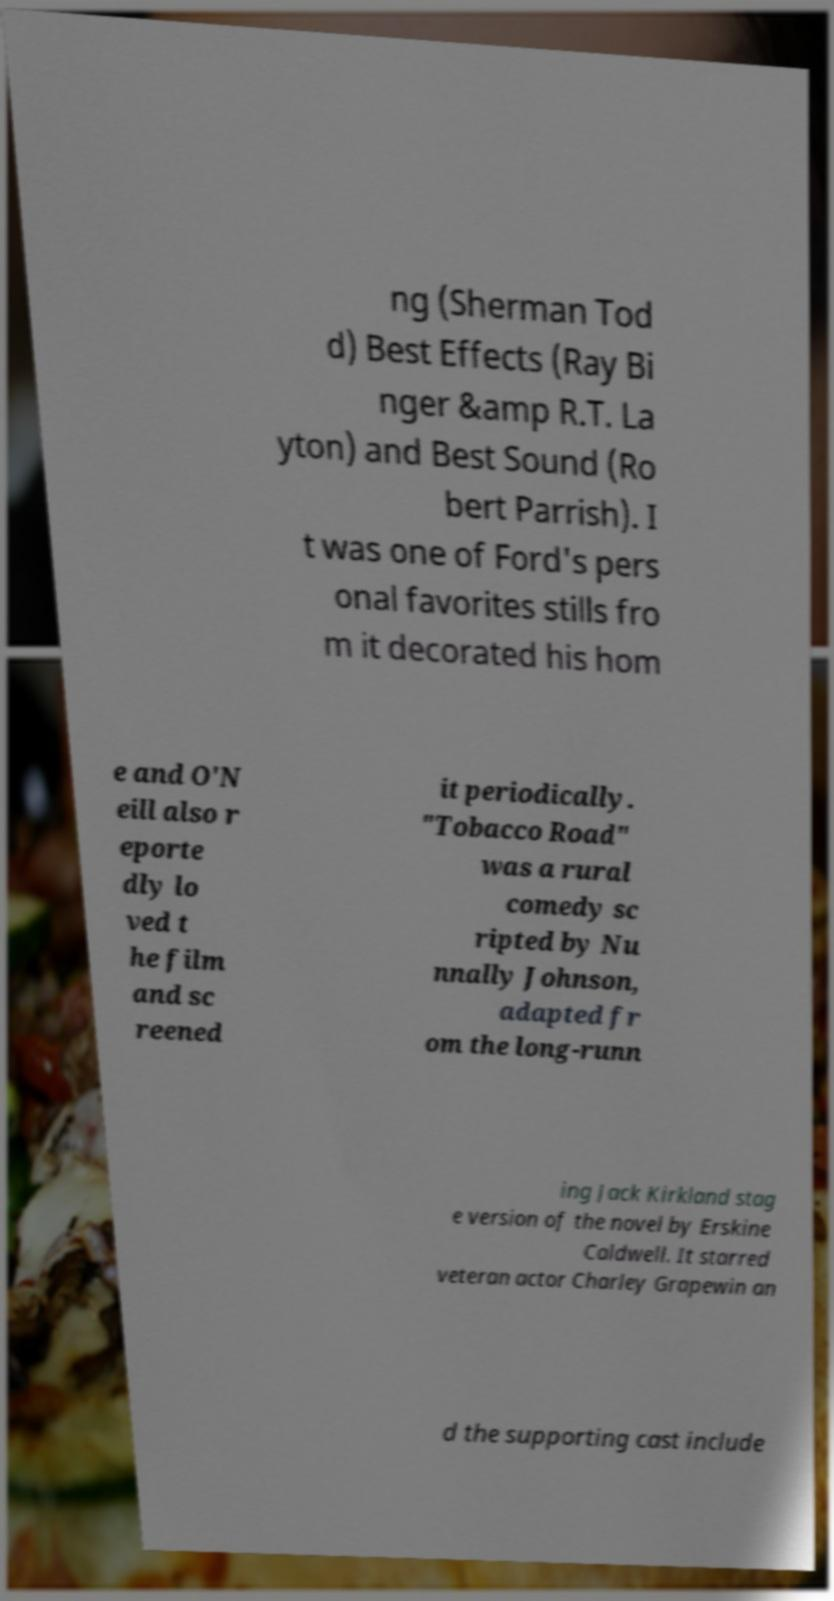There's text embedded in this image that I need extracted. Can you transcribe it verbatim? ng (Sherman Tod d) Best Effects (Ray Bi nger &amp R.T. La yton) and Best Sound (Ro bert Parrish). I t was one of Ford's pers onal favorites stills fro m it decorated his hom e and O'N eill also r eporte dly lo ved t he film and sc reened it periodically. "Tobacco Road" was a rural comedy sc ripted by Nu nnally Johnson, adapted fr om the long-runn ing Jack Kirkland stag e version of the novel by Erskine Caldwell. It starred veteran actor Charley Grapewin an d the supporting cast include 